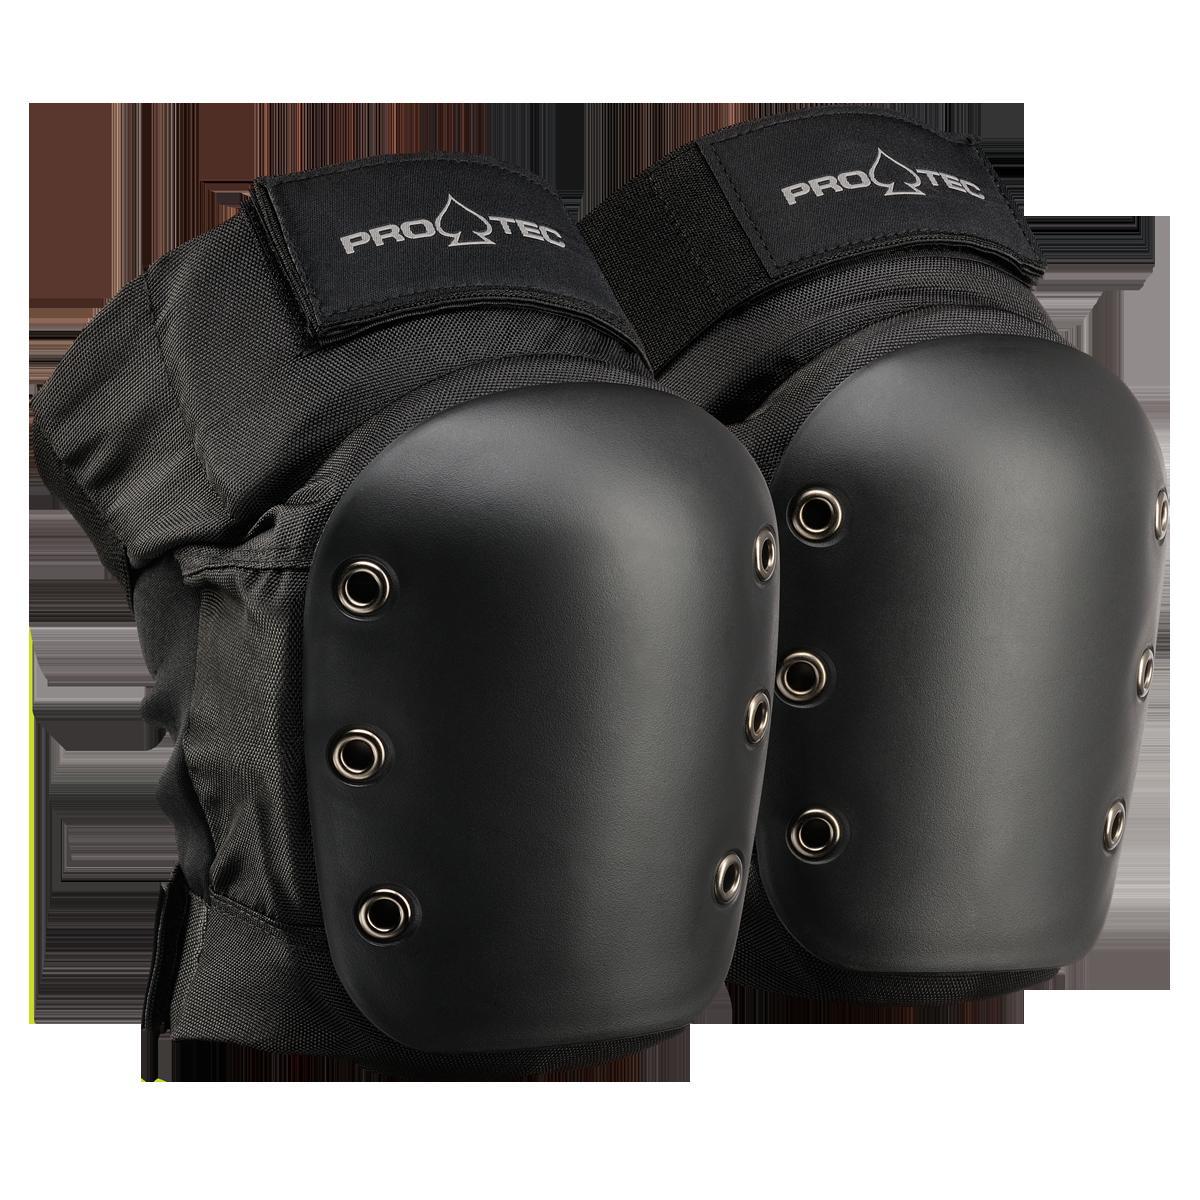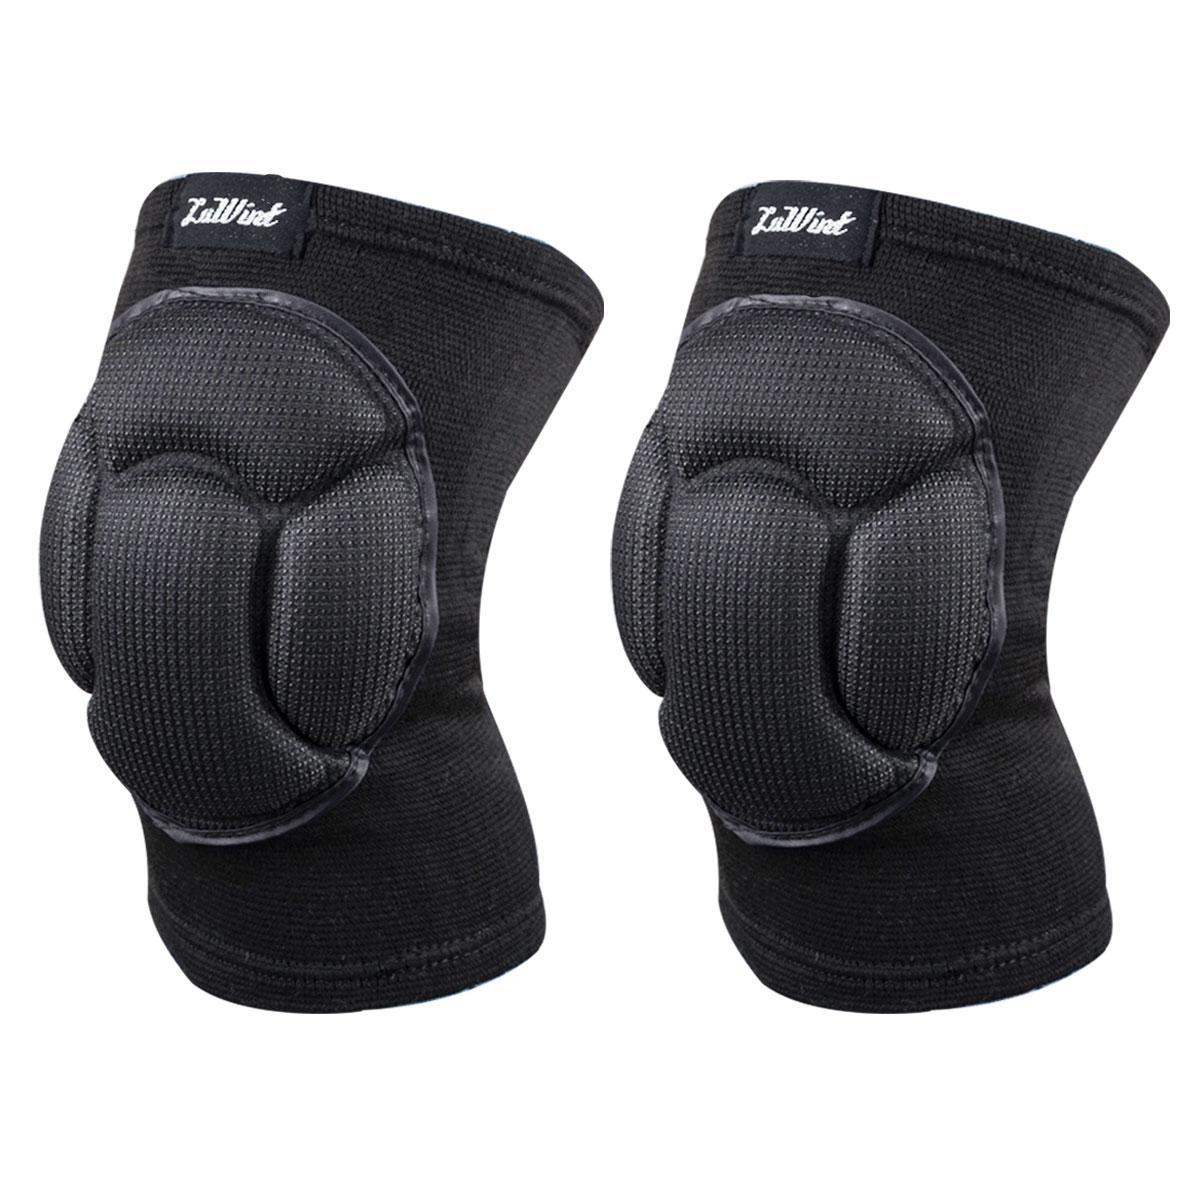The first image is the image on the left, the second image is the image on the right. Examine the images to the left and right. Is the description "One of the pairs of pads is incomplete." accurate? Answer yes or no. No. The first image is the image on the left, the second image is the image on the right. For the images displayed, is the sentence "Each image shows a pair of black knee pads." factually correct? Answer yes or no. Yes. 